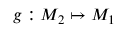Convert formula to latex. <formula><loc_0><loc_0><loc_500><loc_500>g \colon M _ { 2 } \mapsto M _ { 1 }</formula> 